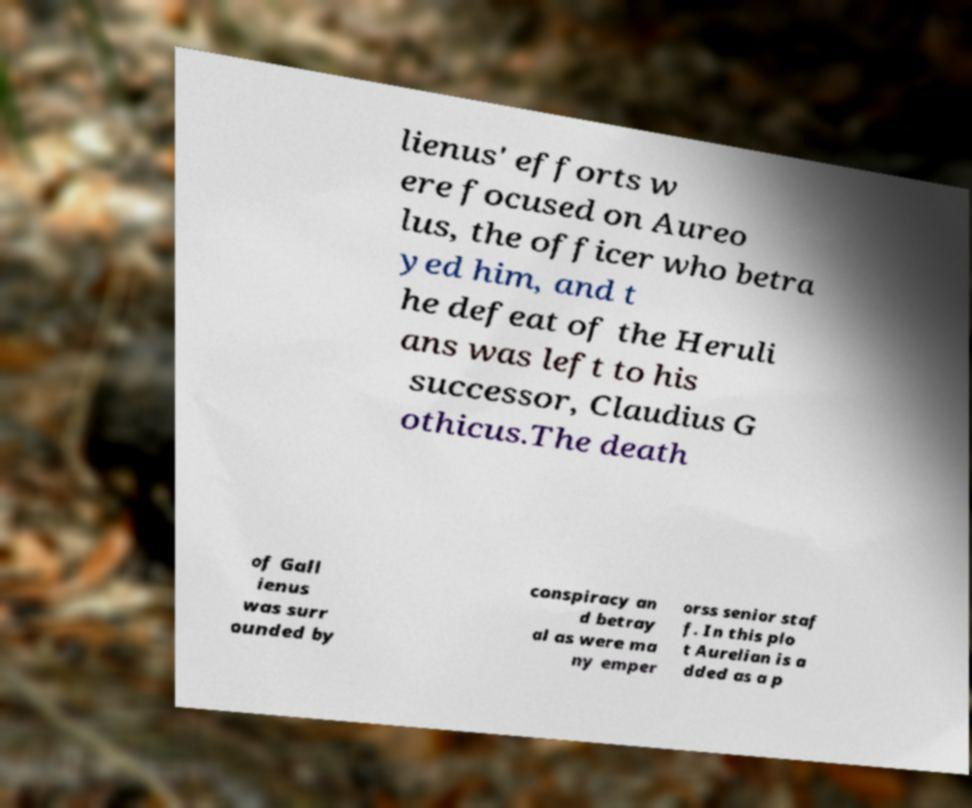For documentation purposes, I need the text within this image transcribed. Could you provide that? lienus' efforts w ere focused on Aureo lus, the officer who betra yed him, and t he defeat of the Heruli ans was left to his successor, Claudius G othicus.The death of Gall ienus was surr ounded by conspiracy an d betray al as were ma ny emper orss senior staf f. In this plo t Aurelian is a dded as a p 